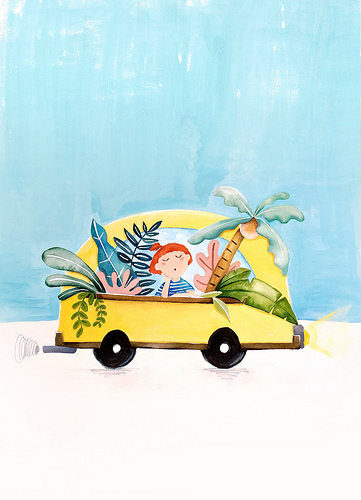<image>
Can you confirm if the palm tree is behind the car? No. The palm tree is not behind the car. From this viewpoint, the palm tree appears to be positioned elsewhere in the scene. 